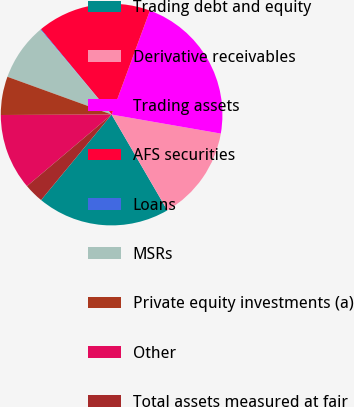Convert chart to OTSL. <chart><loc_0><loc_0><loc_500><loc_500><pie_chart><fcel>Trading debt and equity<fcel>Derivative receivables<fcel>Trading assets<fcel>AFS securities<fcel>Loans<fcel>MSRs<fcel>Private equity investments (a)<fcel>Other<fcel>Total assets measured at fair<nl><fcel>19.37%<fcel>13.87%<fcel>22.13%<fcel>16.62%<fcel>0.1%<fcel>8.36%<fcel>5.6%<fcel>11.11%<fcel>2.85%<nl></chart> 